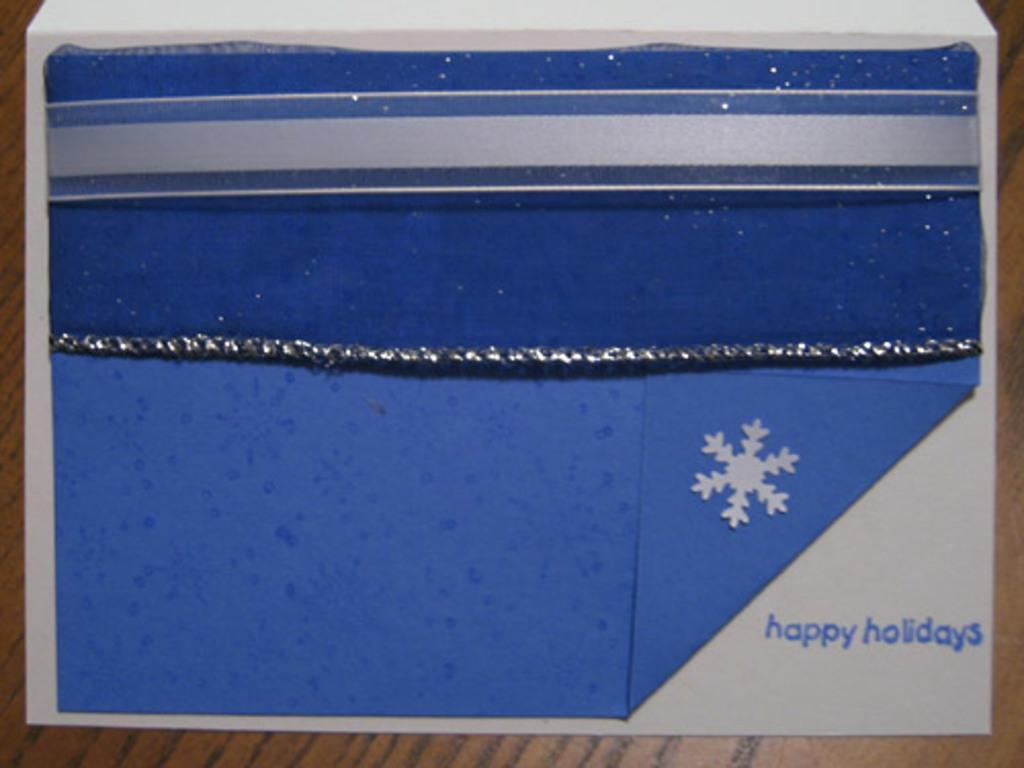<image>
Describe the image concisely. Handmade blue and white greeting card stating Happy Holidays. 